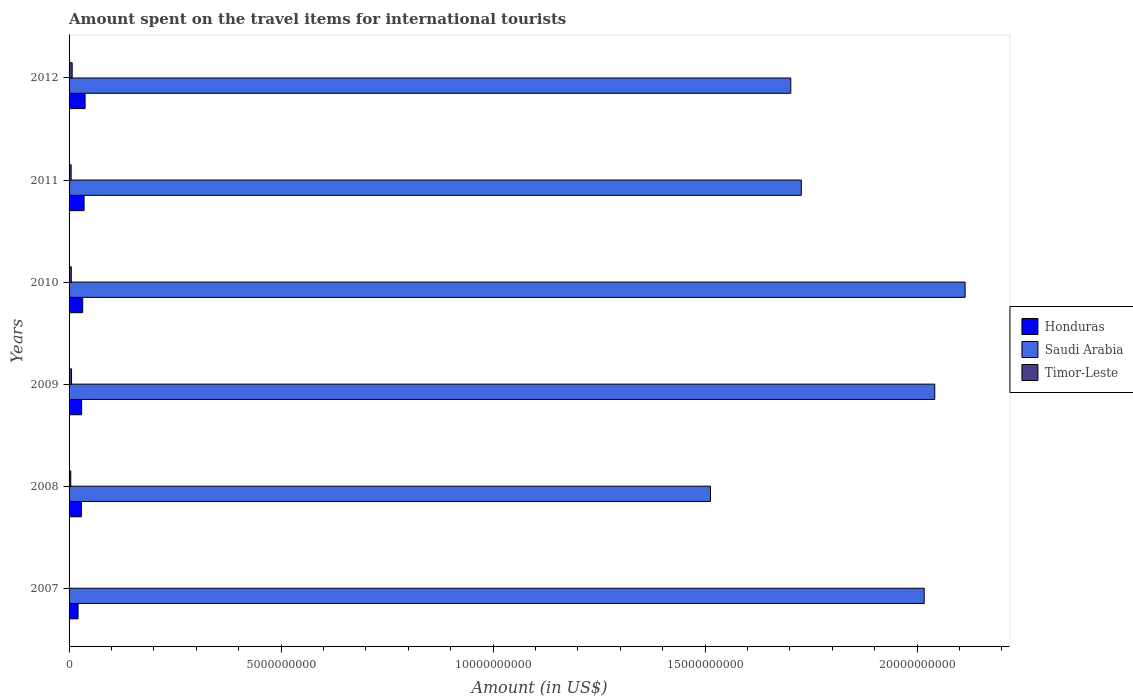How many groups of bars are there?
Your response must be concise. 6. What is the label of the 4th group of bars from the top?
Offer a terse response. 2009. What is the amount spent on the travel items for international tourists in Timor-Leste in 2009?
Offer a very short reply. 5.80e+07. Across all years, what is the maximum amount spent on the travel items for international tourists in Saudi Arabia?
Your answer should be compact. 2.11e+1. In which year was the amount spent on the travel items for international tourists in Honduras maximum?
Keep it short and to the point. 2012. What is the total amount spent on the travel items for international tourists in Saudi Arabia in the graph?
Provide a succinct answer. 1.11e+11. What is the difference between the amount spent on the travel items for international tourists in Saudi Arabia in 2009 and that in 2010?
Your answer should be compact. -7.16e+08. What is the difference between the amount spent on the travel items for international tourists in Honduras in 2011 and the amount spent on the travel items for international tourists in Timor-Leste in 2012?
Your response must be concise. 2.81e+08. What is the average amount spent on the travel items for international tourists in Saudi Arabia per year?
Make the answer very short. 1.85e+1. In the year 2010, what is the difference between the amount spent on the travel items for international tourists in Timor-Leste and amount spent on the travel items for international tourists in Saudi Arabia?
Your response must be concise. -2.11e+1. What is the ratio of the amount spent on the travel items for international tourists in Honduras in 2007 to that in 2008?
Provide a succinct answer. 0.73. What is the difference between the highest and the second highest amount spent on the travel items for international tourists in Timor-Leste?
Your answer should be compact. 1.50e+07. What is the difference between the highest and the lowest amount spent on the travel items for international tourists in Saudi Arabia?
Keep it short and to the point. 6.01e+09. Is the sum of the amount spent on the travel items for international tourists in Timor-Leste in 2008 and 2012 greater than the maximum amount spent on the travel items for international tourists in Saudi Arabia across all years?
Offer a terse response. No. What does the 1st bar from the top in 2010 represents?
Ensure brevity in your answer.  Timor-Leste. What does the 3rd bar from the bottom in 2011 represents?
Make the answer very short. Timor-Leste. Is it the case that in every year, the sum of the amount spent on the travel items for international tourists in Saudi Arabia and amount spent on the travel items for international tourists in Timor-Leste is greater than the amount spent on the travel items for international tourists in Honduras?
Your answer should be very brief. Yes. How many bars are there?
Make the answer very short. 18. How many years are there in the graph?
Make the answer very short. 6. Does the graph contain any zero values?
Provide a succinct answer. No. Where does the legend appear in the graph?
Your answer should be compact. Center right. How are the legend labels stacked?
Make the answer very short. Vertical. What is the title of the graph?
Ensure brevity in your answer.  Amount spent on the travel items for international tourists. What is the label or title of the Y-axis?
Your response must be concise. Years. What is the Amount (in US$) of Honduras in 2007?
Offer a terse response. 2.12e+08. What is the Amount (in US$) of Saudi Arabia in 2007?
Your answer should be very brief. 2.02e+1. What is the Amount (in US$) of Honduras in 2008?
Ensure brevity in your answer.  2.91e+08. What is the Amount (in US$) in Saudi Arabia in 2008?
Provide a succinct answer. 1.51e+1. What is the Amount (in US$) in Timor-Leste in 2008?
Ensure brevity in your answer.  4.00e+07. What is the Amount (in US$) in Honduras in 2009?
Make the answer very short. 2.96e+08. What is the Amount (in US$) in Saudi Arabia in 2009?
Your answer should be compact. 2.04e+1. What is the Amount (in US$) in Timor-Leste in 2009?
Provide a short and direct response. 5.80e+07. What is the Amount (in US$) of Honduras in 2010?
Your answer should be very brief. 3.21e+08. What is the Amount (in US$) in Saudi Arabia in 2010?
Your response must be concise. 2.11e+1. What is the Amount (in US$) of Timor-Leste in 2010?
Offer a very short reply. 5.20e+07. What is the Amount (in US$) of Honduras in 2011?
Offer a terse response. 3.54e+08. What is the Amount (in US$) of Saudi Arabia in 2011?
Keep it short and to the point. 1.73e+1. What is the Amount (in US$) of Timor-Leste in 2011?
Offer a terse response. 4.90e+07. What is the Amount (in US$) of Honduras in 2012?
Keep it short and to the point. 3.78e+08. What is the Amount (in US$) of Saudi Arabia in 2012?
Ensure brevity in your answer.  1.70e+1. What is the Amount (in US$) of Timor-Leste in 2012?
Offer a terse response. 7.30e+07. Across all years, what is the maximum Amount (in US$) of Honduras?
Provide a short and direct response. 3.78e+08. Across all years, what is the maximum Amount (in US$) of Saudi Arabia?
Keep it short and to the point. 2.11e+1. Across all years, what is the maximum Amount (in US$) of Timor-Leste?
Your answer should be compact. 7.30e+07. Across all years, what is the minimum Amount (in US$) in Honduras?
Provide a succinct answer. 2.12e+08. Across all years, what is the minimum Amount (in US$) of Saudi Arabia?
Offer a terse response. 1.51e+1. Across all years, what is the minimum Amount (in US$) in Timor-Leste?
Your answer should be compact. 3.00e+06. What is the total Amount (in US$) in Honduras in the graph?
Provide a short and direct response. 1.85e+09. What is the total Amount (in US$) of Saudi Arabia in the graph?
Give a very brief answer. 1.11e+11. What is the total Amount (in US$) in Timor-Leste in the graph?
Provide a short and direct response. 2.75e+08. What is the difference between the Amount (in US$) of Honduras in 2007 and that in 2008?
Provide a succinct answer. -7.90e+07. What is the difference between the Amount (in US$) of Saudi Arabia in 2007 and that in 2008?
Make the answer very short. 5.04e+09. What is the difference between the Amount (in US$) of Timor-Leste in 2007 and that in 2008?
Provide a succinct answer. -3.70e+07. What is the difference between the Amount (in US$) in Honduras in 2007 and that in 2009?
Provide a short and direct response. -8.40e+07. What is the difference between the Amount (in US$) in Saudi Arabia in 2007 and that in 2009?
Keep it short and to the point. -2.49e+08. What is the difference between the Amount (in US$) of Timor-Leste in 2007 and that in 2009?
Keep it short and to the point. -5.50e+07. What is the difference between the Amount (in US$) in Honduras in 2007 and that in 2010?
Ensure brevity in your answer.  -1.09e+08. What is the difference between the Amount (in US$) of Saudi Arabia in 2007 and that in 2010?
Offer a very short reply. -9.65e+08. What is the difference between the Amount (in US$) of Timor-Leste in 2007 and that in 2010?
Offer a very short reply. -4.90e+07. What is the difference between the Amount (in US$) of Honduras in 2007 and that in 2011?
Keep it short and to the point. -1.42e+08. What is the difference between the Amount (in US$) in Saudi Arabia in 2007 and that in 2011?
Offer a terse response. 2.90e+09. What is the difference between the Amount (in US$) in Timor-Leste in 2007 and that in 2011?
Your answer should be very brief. -4.60e+07. What is the difference between the Amount (in US$) of Honduras in 2007 and that in 2012?
Give a very brief answer. -1.66e+08. What is the difference between the Amount (in US$) of Saudi Arabia in 2007 and that in 2012?
Provide a succinct answer. 3.15e+09. What is the difference between the Amount (in US$) of Timor-Leste in 2007 and that in 2012?
Offer a terse response. -7.00e+07. What is the difference between the Amount (in US$) of Honduras in 2008 and that in 2009?
Provide a short and direct response. -5.00e+06. What is the difference between the Amount (in US$) in Saudi Arabia in 2008 and that in 2009?
Your answer should be very brief. -5.29e+09. What is the difference between the Amount (in US$) of Timor-Leste in 2008 and that in 2009?
Provide a short and direct response. -1.80e+07. What is the difference between the Amount (in US$) of Honduras in 2008 and that in 2010?
Keep it short and to the point. -3.00e+07. What is the difference between the Amount (in US$) in Saudi Arabia in 2008 and that in 2010?
Offer a terse response. -6.01e+09. What is the difference between the Amount (in US$) in Timor-Leste in 2008 and that in 2010?
Your response must be concise. -1.20e+07. What is the difference between the Amount (in US$) in Honduras in 2008 and that in 2011?
Your answer should be very brief. -6.30e+07. What is the difference between the Amount (in US$) of Saudi Arabia in 2008 and that in 2011?
Offer a terse response. -2.14e+09. What is the difference between the Amount (in US$) in Timor-Leste in 2008 and that in 2011?
Provide a succinct answer. -9.00e+06. What is the difference between the Amount (in US$) in Honduras in 2008 and that in 2012?
Offer a terse response. -8.70e+07. What is the difference between the Amount (in US$) of Saudi Arabia in 2008 and that in 2012?
Your answer should be compact. -1.89e+09. What is the difference between the Amount (in US$) of Timor-Leste in 2008 and that in 2012?
Make the answer very short. -3.30e+07. What is the difference between the Amount (in US$) in Honduras in 2009 and that in 2010?
Give a very brief answer. -2.50e+07. What is the difference between the Amount (in US$) in Saudi Arabia in 2009 and that in 2010?
Provide a short and direct response. -7.16e+08. What is the difference between the Amount (in US$) of Honduras in 2009 and that in 2011?
Your response must be concise. -5.80e+07. What is the difference between the Amount (in US$) in Saudi Arabia in 2009 and that in 2011?
Give a very brief answer. 3.15e+09. What is the difference between the Amount (in US$) of Timor-Leste in 2009 and that in 2011?
Make the answer very short. 9.00e+06. What is the difference between the Amount (in US$) in Honduras in 2009 and that in 2012?
Your answer should be compact. -8.20e+07. What is the difference between the Amount (in US$) of Saudi Arabia in 2009 and that in 2012?
Provide a succinct answer. 3.40e+09. What is the difference between the Amount (in US$) of Timor-Leste in 2009 and that in 2012?
Your answer should be compact. -1.50e+07. What is the difference between the Amount (in US$) of Honduras in 2010 and that in 2011?
Offer a very short reply. -3.30e+07. What is the difference between the Amount (in US$) in Saudi Arabia in 2010 and that in 2011?
Your answer should be very brief. 3.86e+09. What is the difference between the Amount (in US$) in Timor-Leste in 2010 and that in 2011?
Give a very brief answer. 3.00e+06. What is the difference between the Amount (in US$) of Honduras in 2010 and that in 2012?
Offer a terse response. -5.70e+07. What is the difference between the Amount (in US$) in Saudi Arabia in 2010 and that in 2012?
Ensure brevity in your answer.  4.11e+09. What is the difference between the Amount (in US$) of Timor-Leste in 2010 and that in 2012?
Offer a terse response. -2.10e+07. What is the difference between the Amount (in US$) in Honduras in 2011 and that in 2012?
Give a very brief answer. -2.40e+07. What is the difference between the Amount (in US$) in Saudi Arabia in 2011 and that in 2012?
Keep it short and to the point. 2.48e+08. What is the difference between the Amount (in US$) in Timor-Leste in 2011 and that in 2012?
Your response must be concise. -2.40e+07. What is the difference between the Amount (in US$) of Honduras in 2007 and the Amount (in US$) of Saudi Arabia in 2008?
Give a very brief answer. -1.49e+1. What is the difference between the Amount (in US$) in Honduras in 2007 and the Amount (in US$) in Timor-Leste in 2008?
Provide a short and direct response. 1.72e+08. What is the difference between the Amount (in US$) of Saudi Arabia in 2007 and the Amount (in US$) of Timor-Leste in 2008?
Give a very brief answer. 2.01e+1. What is the difference between the Amount (in US$) of Honduras in 2007 and the Amount (in US$) of Saudi Arabia in 2009?
Keep it short and to the point. -2.02e+1. What is the difference between the Amount (in US$) of Honduras in 2007 and the Amount (in US$) of Timor-Leste in 2009?
Offer a very short reply. 1.54e+08. What is the difference between the Amount (in US$) in Saudi Arabia in 2007 and the Amount (in US$) in Timor-Leste in 2009?
Make the answer very short. 2.01e+1. What is the difference between the Amount (in US$) in Honduras in 2007 and the Amount (in US$) in Saudi Arabia in 2010?
Offer a terse response. -2.09e+1. What is the difference between the Amount (in US$) in Honduras in 2007 and the Amount (in US$) in Timor-Leste in 2010?
Make the answer very short. 1.60e+08. What is the difference between the Amount (in US$) in Saudi Arabia in 2007 and the Amount (in US$) in Timor-Leste in 2010?
Make the answer very short. 2.01e+1. What is the difference between the Amount (in US$) in Honduras in 2007 and the Amount (in US$) in Saudi Arabia in 2011?
Your answer should be very brief. -1.71e+1. What is the difference between the Amount (in US$) in Honduras in 2007 and the Amount (in US$) in Timor-Leste in 2011?
Ensure brevity in your answer.  1.63e+08. What is the difference between the Amount (in US$) of Saudi Arabia in 2007 and the Amount (in US$) of Timor-Leste in 2011?
Offer a very short reply. 2.01e+1. What is the difference between the Amount (in US$) in Honduras in 2007 and the Amount (in US$) in Saudi Arabia in 2012?
Your answer should be very brief. -1.68e+1. What is the difference between the Amount (in US$) in Honduras in 2007 and the Amount (in US$) in Timor-Leste in 2012?
Provide a short and direct response. 1.39e+08. What is the difference between the Amount (in US$) of Saudi Arabia in 2007 and the Amount (in US$) of Timor-Leste in 2012?
Ensure brevity in your answer.  2.01e+1. What is the difference between the Amount (in US$) in Honduras in 2008 and the Amount (in US$) in Saudi Arabia in 2009?
Your answer should be very brief. -2.01e+1. What is the difference between the Amount (in US$) in Honduras in 2008 and the Amount (in US$) in Timor-Leste in 2009?
Offer a very short reply. 2.33e+08. What is the difference between the Amount (in US$) of Saudi Arabia in 2008 and the Amount (in US$) of Timor-Leste in 2009?
Offer a terse response. 1.51e+1. What is the difference between the Amount (in US$) in Honduras in 2008 and the Amount (in US$) in Saudi Arabia in 2010?
Your answer should be compact. -2.08e+1. What is the difference between the Amount (in US$) of Honduras in 2008 and the Amount (in US$) of Timor-Leste in 2010?
Ensure brevity in your answer.  2.39e+08. What is the difference between the Amount (in US$) in Saudi Arabia in 2008 and the Amount (in US$) in Timor-Leste in 2010?
Your answer should be very brief. 1.51e+1. What is the difference between the Amount (in US$) in Honduras in 2008 and the Amount (in US$) in Saudi Arabia in 2011?
Keep it short and to the point. -1.70e+1. What is the difference between the Amount (in US$) of Honduras in 2008 and the Amount (in US$) of Timor-Leste in 2011?
Your response must be concise. 2.42e+08. What is the difference between the Amount (in US$) of Saudi Arabia in 2008 and the Amount (in US$) of Timor-Leste in 2011?
Make the answer very short. 1.51e+1. What is the difference between the Amount (in US$) of Honduras in 2008 and the Amount (in US$) of Saudi Arabia in 2012?
Provide a succinct answer. -1.67e+1. What is the difference between the Amount (in US$) of Honduras in 2008 and the Amount (in US$) of Timor-Leste in 2012?
Keep it short and to the point. 2.18e+08. What is the difference between the Amount (in US$) in Saudi Arabia in 2008 and the Amount (in US$) in Timor-Leste in 2012?
Give a very brief answer. 1.51e+1. What is the difference between the Amount (in US$) in Honduras in 2009 and the Amount (in US$) in Saudi Arabia in 2010?
Offer a very short reply. -2.08e+1. What is the difference between the Amount (in US$) of Honduras in 2009 and the Amount (in US$) of Timor-Leste in 2010?
Your response must be concise. 2.44e+08. What is the difference between the Amount (in US$) in Saudi Arabia in 2009 and the Amount (in US$) in Timor-Leste in 2010?
Ensure brevity in your answer.  2.04e+1. What is the difference between the Amount (in US$) of Honduras in 2009 and the Amount (in US$) of Saudi Arabia in 2011?
Offer a very short reply. -1.70e+1. What is the difference between the Amount (in US$) in Honduras in 2009 and the Amount (in US$) in Timor-Leste in 2011?
Ensure brevity in your answer.  2.47e+08. What is the difference between the Amount (in US$) in Saudi Arabia in 2009 and the Amount (in US$) in Timor-Leste in 2011?
Offer a very short reply. 2.04e+1. What is the difference between the Amount (in US$) in Honduras in 2009 and the Amount (in US$) in Saudi Arabia in 2012?
Your answer should be very brief. -1.67e+1. What is the difference between the Amount (in US$) in Honduras in 2009 and the Amount (in US$) in Timor-Leste in 2012?
Your answer should be compact. 2.23e+08. What is the difference between the Amount (in US$) in Saudi Arabia in 2009 and the Amount (in US$) in Timor-Leste in 2012?
Provide a succinct answer. 2.03e+1. What is the difference between the Amount (in US$) of Honduras in 2010 and the Amount (in US$) of Saudi Arabia in 2011?
Make the answer very short. -1.70e+1. What is the difference between the Amount (in US$) in Honduras in 2010 and the Amount (in US$) in Timor-Leste in 2011?
Make the answer very short. 2.72e+08. What is the difference between the Amount (in US$) of Saudi Arabia in 2010 and the Amount (in US$) of Timor-Leste in 2011?
Ensure brevity in your answer.  2.11e+1. What is the difference between the Amount (in US$) in Honduras in 2010 and the Amount (in US$) in Saudi Arabia in 2012?
Your answer should be compact. -1.67e+1. What is the difference between the Amount (in US$) in Honduras in 2010 and the Amount (in US$) in Timor-Leste in 2012?
Make the answer very short. 2.48e+08. What is the difference between the Amount (in US$) in Saudi Arabia in 2010 and the Amount (in US$) in Timor-Leste in 2012?
Ensure brevity in your answer.  2.11e+1. What is the difference between the Amount (in US$) in Honduras in 2011 and the Amount (in US$) in Saudi Arabia in 2012?
Make the answer very short. -1.67e+1. What is the difference between the Amount (in US$) of Honduras in 2011 and the Amount (in US$) of Timor-Leste in 2012?
Your answer should be very brief. 2.81e+08. What is the difference between the Amount (in US$) of Saudi Arabia in 2011 and the Amount (in US$) of Timor-Leste in 2012?
Give a very brief answer. 1.72e+1. What is the average Amount (in US$) of Honduras per year?
Ensure brevity in your answer.  3.09e+08. What is the average Amount (in US$) in Saudi Arabia per year?
Provide a short and direct response. 1.85e+1. What is the average Amount (in US$) of Timor-Leste per year?
Your response must be concise. 4.58e+07. In the year 2007, what is the difference between the Amount (in US$) in Honduras and Amount (in US$) in Saudi Arabia?
Your response must be concise. -2.00e+1. In the year 2007, what is the difference between the Amount (in US$) in Honduras and Amount (in US$) in Timor-Leste?
Offer a very short reply. 2.09e+08. In the year 2007, what is the difference between the Amount (in US$) in Saudi Arabia and Amount (in US$) in Timor-Leste?
Make the answer very short. 2.02e+1. In the year 2008, what is the difference between the Amount (in US$) in Honduras and Amount (in US$) in Saudi Arabia?
Your answer should be compact. -1.48e+1. In the year 2008, what is the difference between the Amount (in US$) in Honduras and Amount (in US$) in Timor-Leste?
Provide a short and direct response. 2.51e+08. In the year 2008, what is the difference between the Amount (in US$) of Saudi Arabia and Amount (in US$) of Timor-Leste?
Ensure brevity in your answer.  1.51e+1. In the year 2009, what is the difference between the Amount (in US$) in Honduras and Amount (in US$) in Saudi Arabia?
Make the answer very short. -2.01e+1. In the year 2009, what is the difference between the Amount (in US$) of Honduras and Amount (in US$) of Timor-Leste?
Your answer should be very brief. 2.38e+08. In the year 2009, what is the difference between the Amount (in US$) of Saudi Arabia and Amount (in US$) of Timor-Leste?
Keep it short and to the point. 2.04e+1. In the year 2010, what is the difference between the Amount (in US$) of Honduras and Amount (in US$) of Saudi Arabia?
Your answer should be very brief. -2.08e+1. In the year 2010, what is the difference between the Amount (in US$) of Honduras and Amount (in US$) of Timor-Leste?
Make the answer very short. 2.69e+08. In the year 2010, what is the difference between the Amount (in US$) of Saudi Arabia and Amount (in US$) of Timor-Leste?
Offer a very short reply. 2.11e+1. In the year 2011, what is the difference between the Amount (in US$) in Honduras and Amount (in US$) in Saudi Arabia?
Ensure brevity in your answer.  -1.69e+1. In the year 2011, what is the difference between the Amount (in US$) of Honduras and Amount (in US$) of Timor-Leste?
Give a very brief answer. 3.05e+08. In the year 2011, what is the difference between the Amount (in US$) in Saudi Arabia and Amount (in US$) in Timor-Leste?
Provide a short and direct response. 1.72e+1. In the year 2012, what is the difference between the Amount (in US$) in Honduras and Amount (in US$) in Saudi Arabia?
Offer a terse response. -1.66e+1. In the year 2012, what is the difference between the Amount (in US$) in Honduras and Amount (in US$) in Timor-Leste?
Give a very brief answer. 3.05e+08. In the year 2012, what is the difference between the Amount (in US$) in Saudi Arabia and Amount (in US$) in Timor-Leste?
Give a very brief answer. 1.70e+1. What is the ratio of the Amount (in US$) in Honduras in 2007 to that in 2008?
Ensure brevity in your answer.  0.73. What is the ratio of the Amount (in US$) of Saudi Arabia in 2007 to that in 2008?
Make the answer very short. 1.33. What is the ratio of the Amount (in US$) in Timor-Leste in 2007 to that in 2008?
Your answer should be compact. 0.07. What is the ratio of the Amount (in US$) of Honduras in 2007 to that in 2009?
Give a very brief answer. 0.72. What is the ratio of the Amount (in US$) in Saudi Arabia in 2007 to that in 2009?
Your response must be concise. 0.99. What is the ratio of the Amount (in US$) in Timor-Leste in 2007 to that in 2009?
Provide a short and direct response. 0.05. What is the ratio of the Amount (in US$) of Honduras in 2007 to that in 2010?
Provide a short and direct response. 0.66. What is the ratio of the Amount (in US$) in Saudi Arabia in 2007 to that in 2010?
Provide a short and direct response. 0.95. What is the ratio of the Amount (in US$) of Timor-Leste in 2007 to that in 2010?
Your answer should be compact. 0.06. What is the ratio of the Amount (in US$) of Honduras in 2007 to that in 2011?
Your answer should be compact. 0.6. What is the ratio of the Amount (in US$) of Saudi Arabia in 2007 to that in 2011?
Your response must be concise. 1.17. What is the ratio of the Amount (in US$) of Timor-Leste in 2007 to that in 2011?
Your answer should be compact. 0.06. What is the ratio of the Amount (in US$) in Honduras in 2007 to that in 2012?
Offer a very short reply. 0.56. What is the ratio of the Amount (in US$) in Saudi Arabia in 2007 to that in 2012?
Provide a succinct answer. 1.18. What is the ratio of the Amount (in US$) in Timor-Leste in 2007 to that in 2012?
Your response must be concise. 0.04. What is the ratio of the Amount (in US$) of Honduras in 2008 to that in 2009?
Your answer should be compact. 0.98. What is the ratio of the Amount (in US$) in Saudi Arabia in 2008 to that in 2009?
Your answer should be compact. 0.74. What is the ratio of the Amount (in US$) of Timor-Leste in 2008 to that in 2009?
Ensure brevity in your answer.  0.69. What is the ratio of the Amount (in US$) of Honduras in 2008 to that in 2010?
Your response must be concise. 0.91. What is the ratio of the Amount (in US$) in Saudi Arabia in 2008 to that in 2010?
Ensure brevity in your answer.  0.72. What is the ratio of the Amount (in US$) of Timor-Leste in 2008 to that in 2010?
Provide a short and direct response. 0.77. What is the ratio of the Amount (in US$) in Honduras in 2008 to that in 2011?
Your response must be concise. 0.82. What is the ratio of the Amount (in US$) of Saudi Arabia in 2008 to that in 2011?
Your answer should be compact. 0.88. What is the ratio of the Amount (in US$) of Timor-Leste in 2008 to that in 2011?
Give a very brief answer. 0.82. What is the ratio of the Amount (in US$) in Honduras in 2008 to that in 2012?
Keep it short and to the point. 0.77. What is the ratio of the Amount (in US$) of Saudi Arabia in 2008 to that in 2012?
Make the answer very short. 0.89. What is the ratio of the Amount (in US$) of Timor-Leste in 2008 to that in 2012?
Give a very brief answer. 0.55. What is the ratio of the Amount (in US$) of Honduras in 2009 to that in 2010?
Ensure brevity in your answer.  0.92. What is the ratio of the Amount (in US$) in Saudi Arabia in 2009 to that in 2010?
Offer a very short reply. 0.97. What is the ratio of the Amount (in US$) in Timor-Leste in 2009 to that in 2010?
Make the answer very short. 1.12. What is the ratio of the Amount (in US$) in Honduras in 2009 to that in 2011?
Your answer should be compact. 0.84. What is the ratio of the Amount (in US$) in Saudi Arabia in 2009 to that in 2011?
Provide a succinct answer. 1.18. What is the ratio of the Amount (in US$) in Timor-Leste in 2009 to that in 2011?
Your response must be concise. 1.18. What is the ratio of the Amount (in US$) in Honduras in 2009 to that in 2012?
Provide a short and direct response. 0.78. What is the ratio of the Amount (in US$) in Saudi Arabia in 2009 to that in 2012?
Give a very brief answer. 1.2. What is the ratio of the Amount (in US$) in Timor-Leste in 2009 to that in 2012?
Offer a very short reply. 0.79. What is the ratio of the Amount (in US$) of Honduras in 2010 to that in 2011?
Offer a very short reply. 0.91. What is the ratio of the Amount (in US$) in Saudi Arabia in 2010 to that in 2011?
Provide a short and direct response. 1.22. What is the ratio of the Amount (in US$) of Timor-Leste in 2010 to that in 2011?
Make the answer very short. 1.06. What is the ratio of the Amount (in US$) in Honduras in 2010 to that in 2012?
Your response must be concise. 0.85. What is the ratio of the Amount (in US$) of Saudi Arabia in 2010 to that in 2012?
Your response must be concise. 1.24. What is the ratio of the Amount (in US$) of Timor-Leste in 2010 to that in 2012?
Provide a short and direct response. 0.71. What is the ratio of the Amount (in US$) in Honduras in 2011 to that in 2012?
Give a very brief answer. 0.94. What is the ratio of the Amount (in US$) of Saudi Arabia in 2011 to that in 2012?
Keep it short and to the point. 1.01. What is the ratio of the Amount (in US$) in Timor-Leste in 2011 to that in 2012?
Offer a terse response. 0.67. What is the difference between the highest and the second highest Amount (in US$) in Honduras?
Provide a short and direct response. 2.40e+07. What is the difference between the highest and the second highest Amount (in US$) in Saudi Arabia?
Your response must be concise. 7.16e+08. What is the difference between the highest and the second highest Amount (in US$) of Timor-Leste?
Make the answer very short. 1.50e+07. What is the difference between the highest and the lowest Amount (in US$) in Honduras?
Offer a terse response. 1.66e+08. What is the difference between the highest and the lowest Amount (in US$) in Saudi Arabia?
Offer a very short reply. 6.01e+09. What is the difference between the highest and the lowest Amount (in US$) in Timor-Leste?
Ensure brevity in your answer.  7.00e+07. 